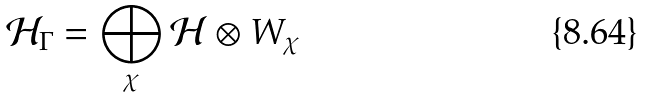<formula> <loc_0><loc_0><loc_500><loc_500>\mathcal { H } _ { \Gamma } = \bigoplus _ { \chi } \mathcal { H } \otimes W _ { \chi }</formula> 